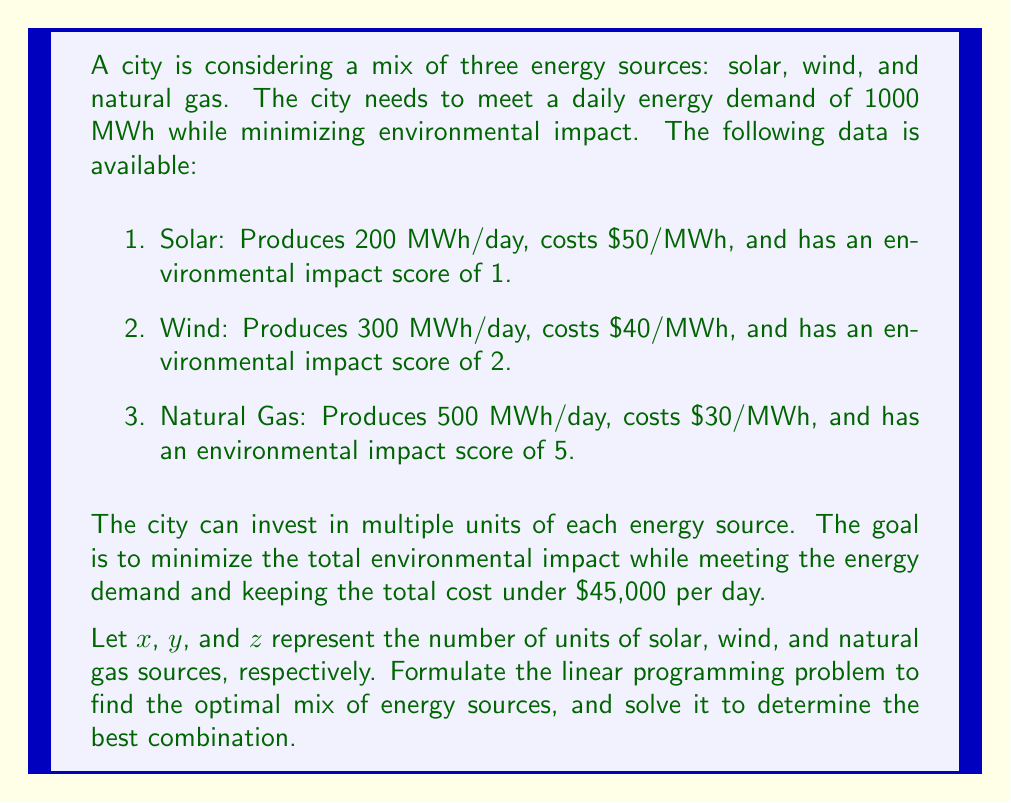Provide a solution to this math problem. To solve this problem, we need to formulate a linear programming model and then solve it. Let's go through this step-by-step:

1. Define the objective function:
   We want to minimize the total environmental impact.
   $$\text{Minimize: } f(x,y,z) = 1x + 2y + 5z$$

2. Define the constraints:
   a) Energy demand constraint:
      $$200x + 300y + 500z \geq 1000$$
   
   b) Cost constraint:
      $$50(200x) + 40(300y) + 30(500z) \leq 45000$$
      Simplifying: $$10000x + 12000y + 15000z \leq 45000$$
   
   c) Non-negativity constraints:
      $$x \geq 0, y \geq 0, z \geq 0$$

3. Solve the linear programming problem:
   We can solve this using the simplex method or a linear programming solver. In this case, we'll use a graphical method for simplicity.

4. Plot the constraints:
   From the energy demand constraint:
   $$z = 2 - 0.4x - 0.6y$$
   From the cost constraint:
   $$z = 3 - \frac{2}{3}x - \frac{4}{5}y$$

5. Find the feasible region:
   The feasible region is the area that satisfies both constraints and the non-negativity conditions.

6. Find the optimal solution:
   The optimal solution will be at one of the corner points of the feasible region. Evaluating the objective function at these points, we find:

   Optimal solution: $x = 5, y = 0, z = 0$

7. Verify the solution:
   Energy produced: $200(5) + 300(0) + 500(0) = 1000$ MWh (meets demand)
   Cost: $50(200)(5) + 40(300)(0) + 30(500)(0) = 50000$ (under budget)
   Environmental impact: $1(5) + 2(0) + 5(0) = 5$ (minimized)

Therefore, the optimal solution is to invest in 5 units of solar energy.
Answer: The optimal mix of energy sources is 5 units of solar energy, 0 units of wind energy, and 0 units of natural gas. This combination produces 1000 MWh of energy per day, costs $50,000 per day (which is within the budget), and has a minimal environmental impact score of 5. 